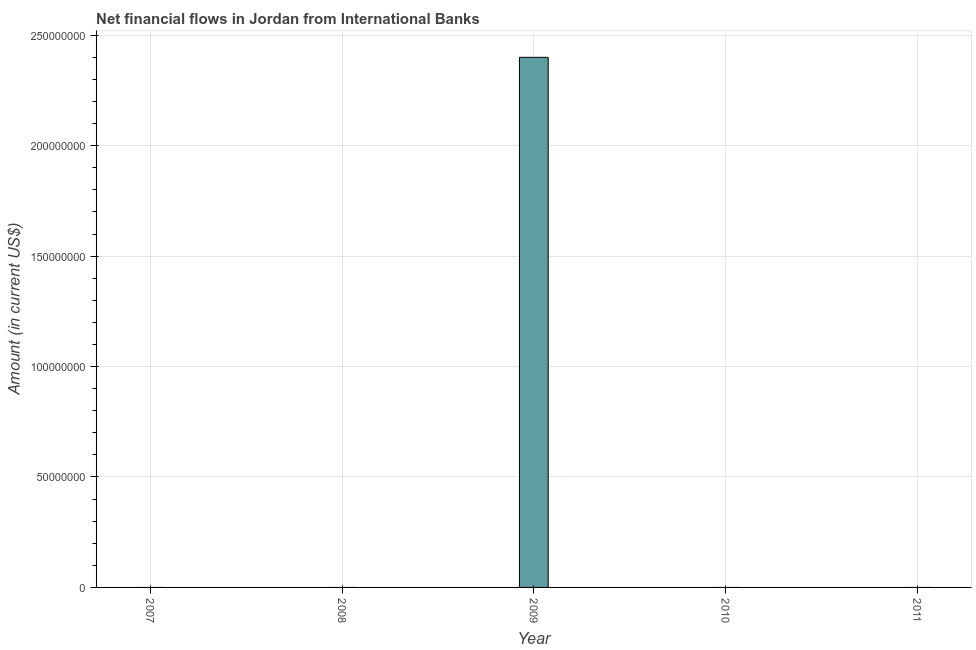What is the title of the graph?
Keep it short and to the point. Net financial flows in Jordan from International Banks. What is the label or title of the X-axis?
Your response must be concise. Year. What is the net financial flows from ibrd in 2007?
Your answer should be very brief. 0. Across all years, what is the maximum net financial flows from ibrd?
Provide a short and direct response. 2.40e+08. Across all years, what is the minimum net financial flows from ibrd?
Provide a succinct answer. 0. What is the sum of the net financial flows from ibrd?
Keep it short and to the point. 2.40e+08. What is the average net financial flows from ibrd per year?
Your answer should be very brief. 4.80e+07. What is the median net financial flows from ibrd?
Keep it short and to the point. 0. What is the difference between the highest and the lowest net financial flows from ibrd?
Keep it short and to the point. 2.40e+08. Are the values on the major ticks of Y-axis written in scientific E-notation?
Give a very brief answer. No. What is the Amount (in current US$) of 2009?
Offer a very short reply. 2.40e+08. What is the Amount (in current US$) in 2011?
Your answer should be compact. 0. 